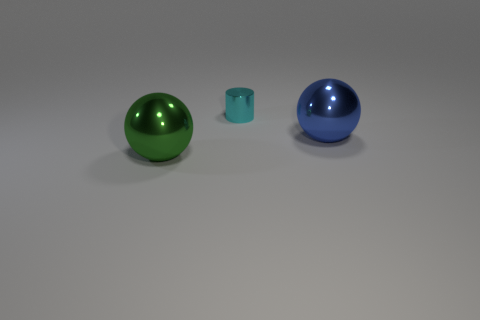Add 3 large green shiny balls. How many objects exist? 6 Subtract all cylinders. How many objects are left? 2 Subtract all blue shiny balls. Subtract all green metallic objects. How many objects are left? 1 Add 1 cyan cylinders. How many cyan cylinders are left? 2 Add 2 tiny yellow metallic cylinders. How many tiny yellow metallic cylinders exist? 2 Subtract 0 brown cubes. How many objects are left? 3 